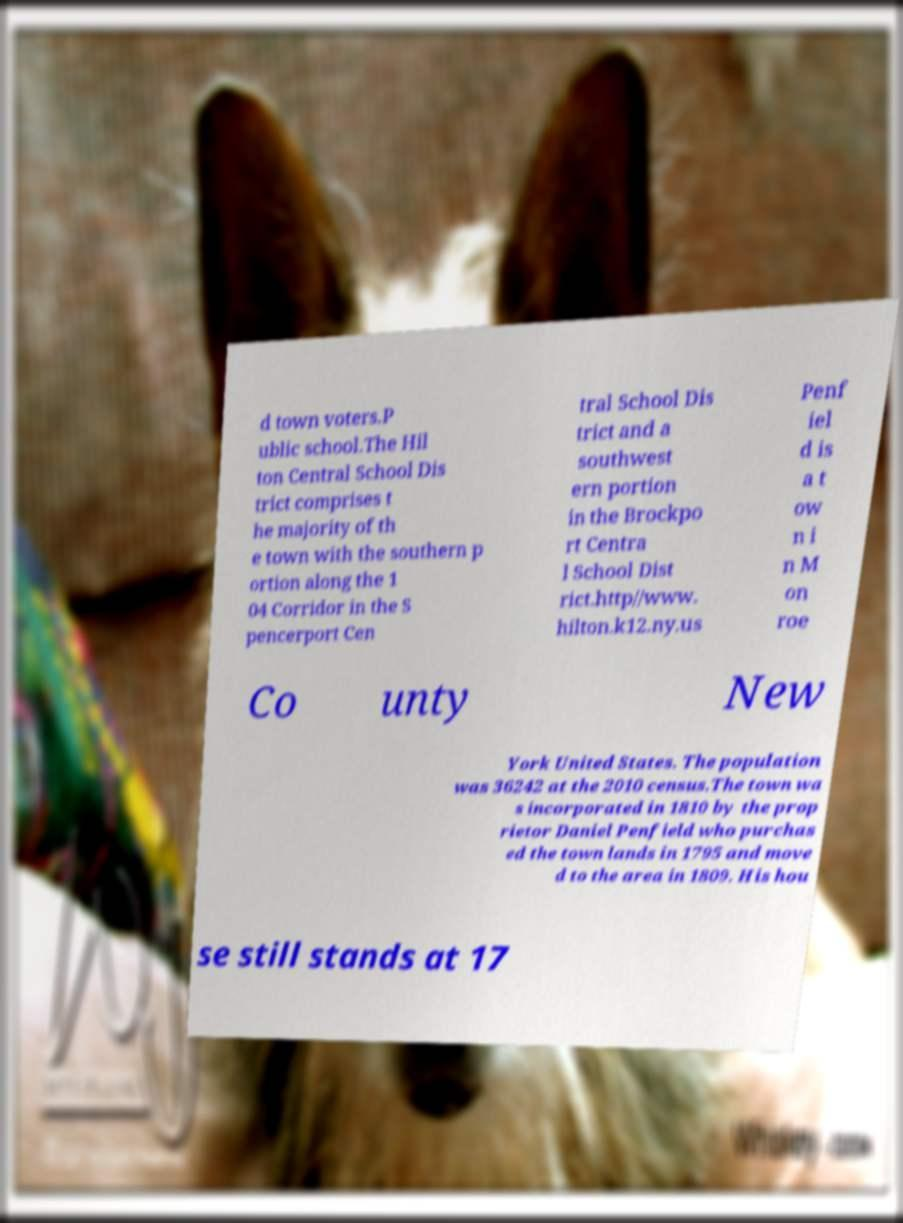Can you read and provide the text displayed in the image?This photo seems to have some interesting text. Can you extract and type it out for me? d town voters.P ublic school.The Hil ton Central School Dis trict comprises t he majority of th e town with the southern p ortion along the 1 04 Corridor in the S pencerport Cen tral School Dis trict and a southwest ern portion in the Brockpo rt Centra l School Dist rict.http//www. hilton.k12.ny.us Penf iel d is a t ow n i n M on roe Co unty New York United States. The population was 36242 at the 2010 census.The town wa s incorporated in 1810 by the prop rietor Daniel Penfield who purchas ed the town lands in 1795 and move d to the area in 1809. His hou se still stands at 17 